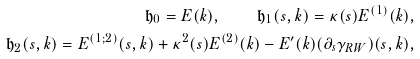Convert formula to latex. <formula><loc_0><loc_0><loc_500><loc_500>\mathfrak { h } _ { 0 } = E ( k ) , \quad \mathfrak { h } _ { 1 } ( s , k ) = \kappa ( s ) E ^ { ( 1 ) } ( k ) , \\ \mathfrak { h } _ { 2 } ( s , k ) = E ^ { ( 1 ; 2 ) } ( s , k ) + \kappa ^ { 2 } ( s ) E ^ { ( 2 ) } ( k ) - E ^ { \prime } ( k ) ( \partial _ { s } \gamma _ { R W } ) ( s , k ) ,</formula> 